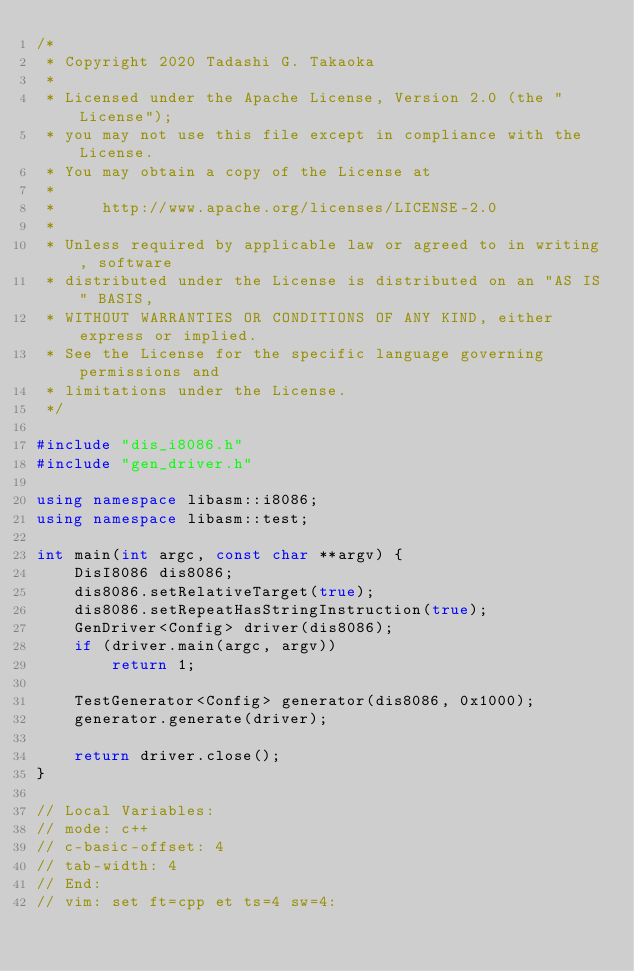Convert code to text. <code><loc_0><loc_0><loc_500><loc_500><_C++_>/*
 * Copyright 2020 Tadashi G. Takaoka
 *
 * Licensed under the Apache License, Version 2.0 (the "License");
 * you may not use this file except in compliance with the License.
 * You may obtain a copy of the License at
 *
 *     http://www.apache.org/licenses/LICENSE-2.0
 *
 * Unless required by applicable law or agreed to in writing, software
 * distributed under the License is distributed on an "AS IS" BASIS,
 * WITHOUT WARRANTIES OR CONDITIONS OF ANY KIND, either express or implied.
 * See the License for the specific language governing permissions and
 * limitations under the License.
 */

#include "dis_i8086.h"
#include "gen_driver.h"

using namespace libasm::i8086;
using namespace libasm::test;

int main(int argc, const char **argv) {
    DisI8086 dis8086;
    dis8086.setRelativeTarget(true);
    dis8086.setRepeatHasStringInstruction(true);
    GenDriver<Config> driver(dis8086);
    if (driver.main(argc, argv))
        return 1;

    TestGenerator<Config> generator(dis8086, 0x1000);
    generator.generate(driver);

    return driver.close();
}

// Local Variables:
// mode: c++
// c-basic-offset: 4
// tab-width: 4
// End:
// vim: set ft=cpp et ts=4 sw=4:
</code> 